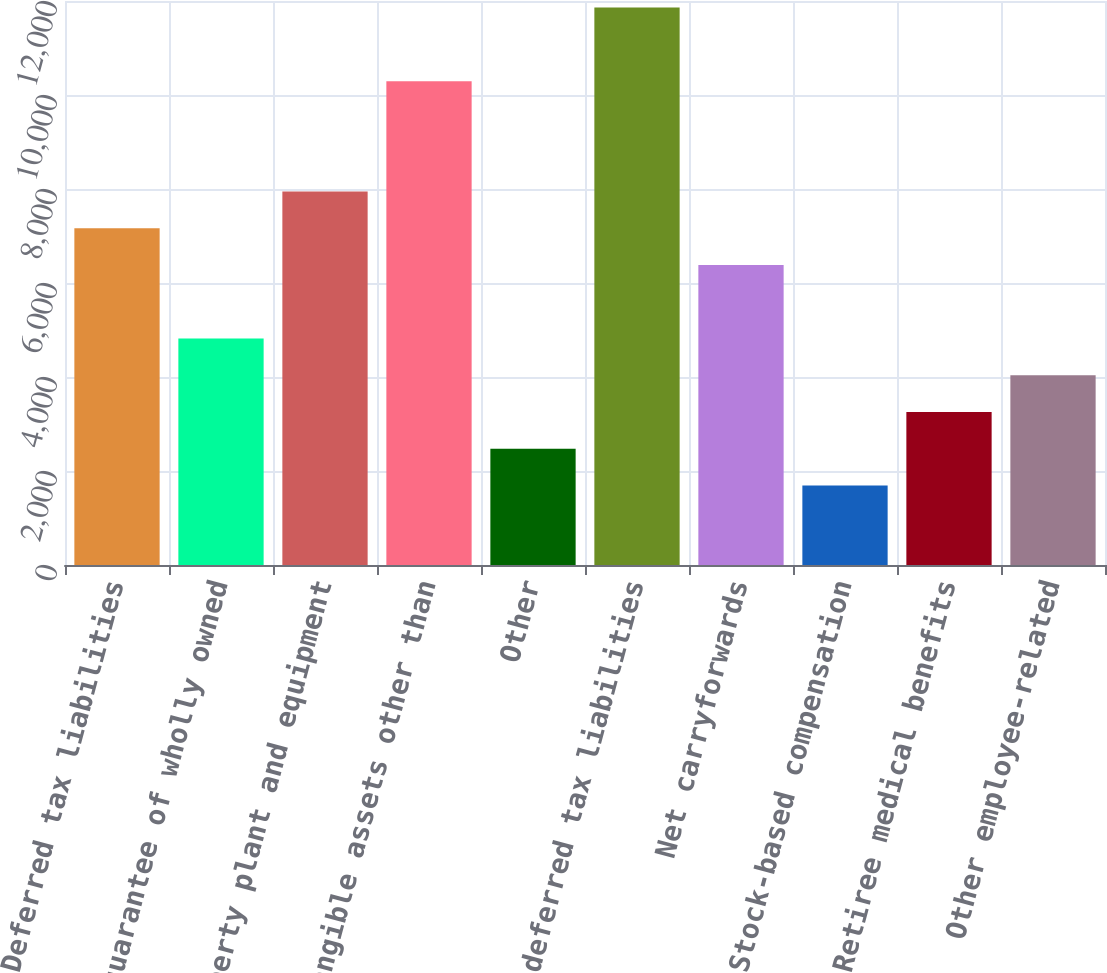<chart> <loc_0><loc_0><loc_500><loc_500><bar_chart><fcel>Deferred tax liabilities<fcel>Debt guarantee of wholly owned<fcel>Property plant and equipment<fcel>Intangible assets other than<fcel>Other<fcel>Gross deferred tax liabilities<fcel>Net carryforwards<fcel>Stock-based compensation<fcel>Retiree medical benefits<fcel>Other employee-related<nl><fcel>7165.7<fcel>4818.8<fcel>7948<fcel>10294.9<fcel>2471.9<fcel>11859.5<fcel>6383.4<fcel>1689.6<fcel>3254.2<fcel>4036.5<nl></chart> 